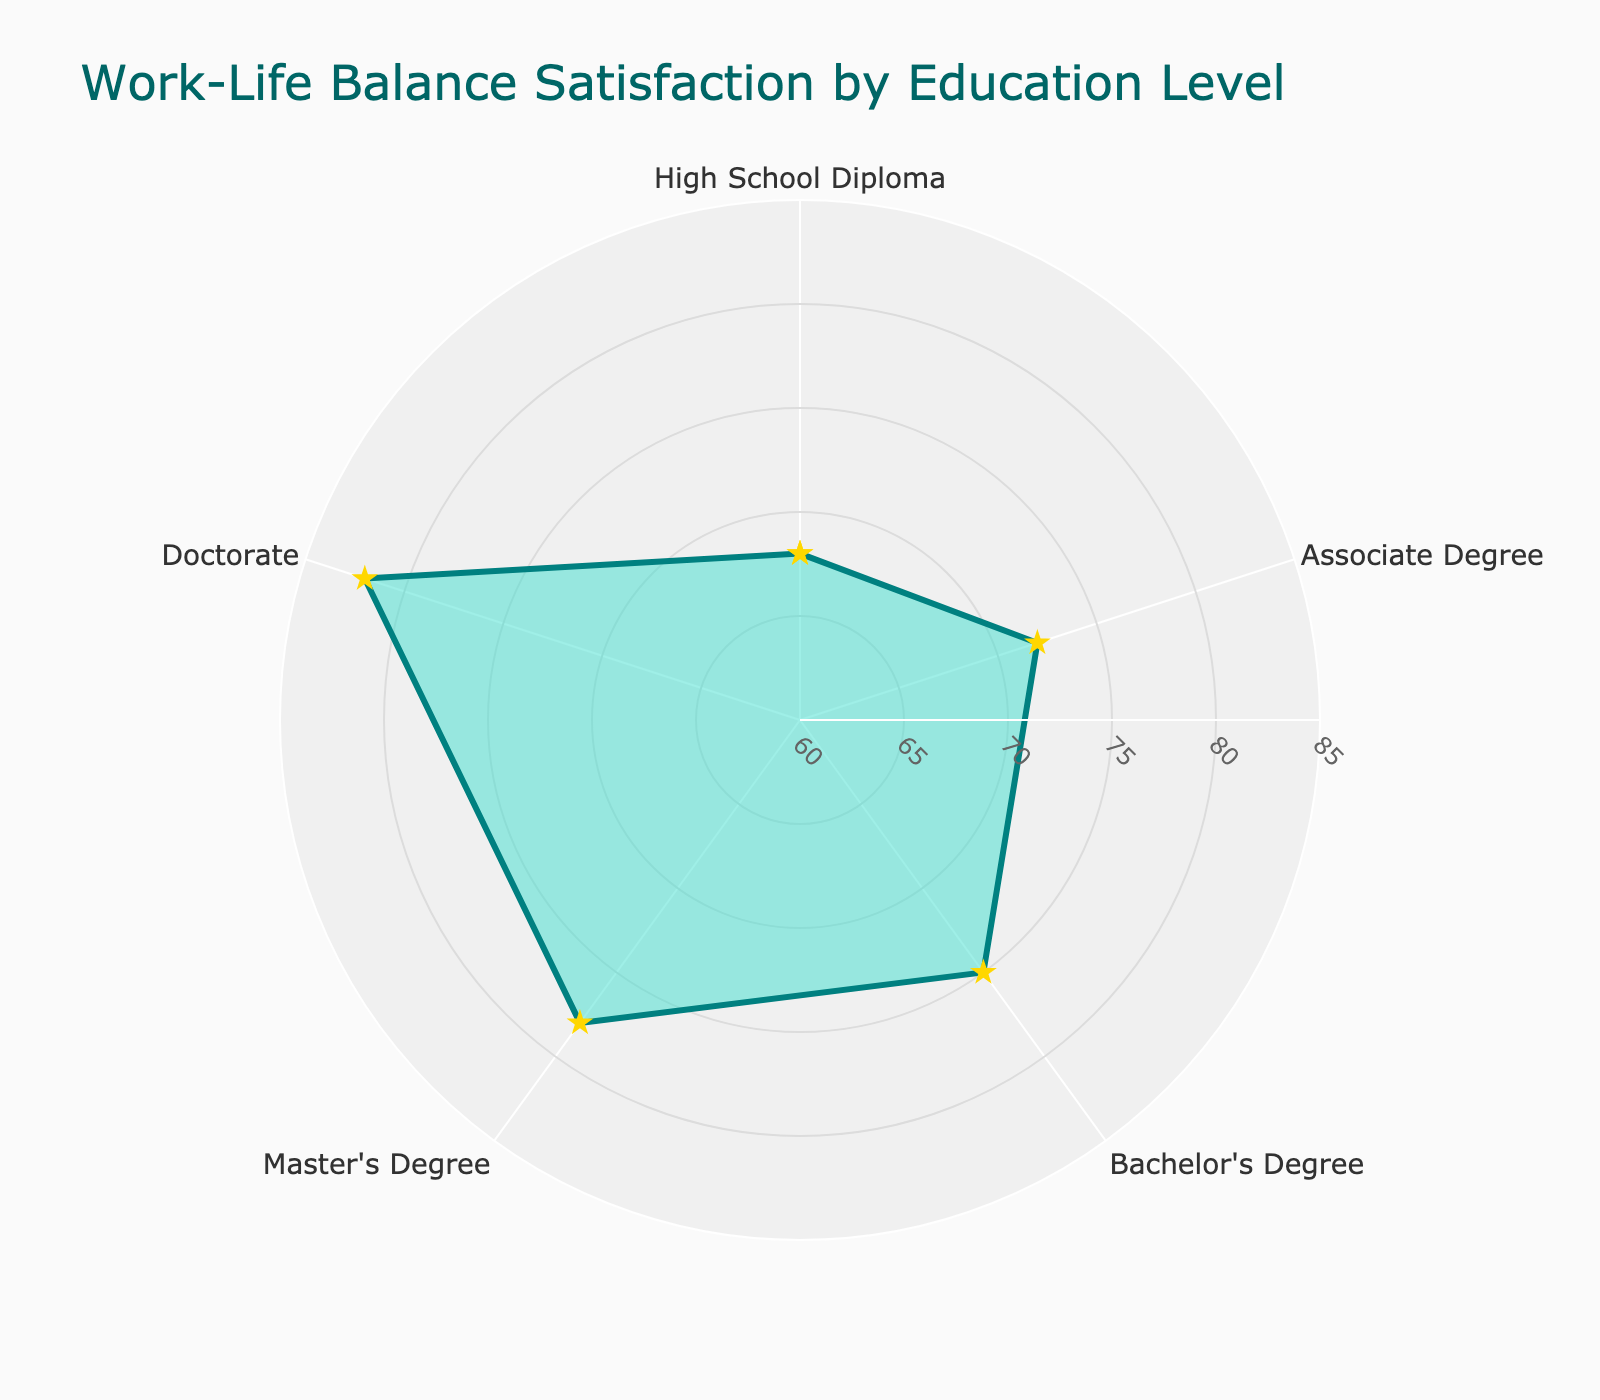what is the title of the radar chart? The title of the chart is located at the top and it summarizes the main topic of the chart. By reading the title, we can easily understand what the chart is about.
Answer: Work-Life Balance Satisfaction by Education Level what is the highest percentage of work-life balance satisfaction and which education level does it belong to? By looking at the largest value on the chart and identifying the corresponding education level, we can determine this information. The highest point is at 82%, corresponding to the Doctorate level.
Answer: 82%, Doctorate which education level has the lowest work-life balance satisfaction percentage? By identifying the lowest value on the chart and matching it with the corresponding education level, the lowest work-life balance satisfaction percentage can be found. The lowest point is at 68%, which corresponds to the High School Diploma level.
Answer: High School Diploma what is the range of work-life balance satisfaction percentages displayed in the radar chart? The range can be calculated by subtracting the lowest value from the highest value. Here, the highest value is 82% (Doctorate) and the lowest value is 68% (High School Diploma). The range is thus 82% - 68%.
Answer: 14% what's the average work-life balance satisfaction percentage across all education levels? To find the average, we sum up all the satisfaction percentages and then divide by the number of education levels: (68 + 72 + 75 + 78 + 82)/5. Adding these together gets 375, and dividing by 5 gives the average.
Answer: 75% which education levels have a work-life balance satisfaction percentage greater than 75%? By examining the percentages on the chart that are greater than 75%, we can determine which education levels meet this criterion. The percentages greater than 75% are 78% (Master's Degree) and 82% (Doctorate).
Answer: Master's Degree, Doctorate how many education levels are represented in the radar chart? We can count the number of unique education levels displayed around the radar chart. They are High School Diploma, Associate Degree, Bachelor's Degree, Master's Degree, and Doctorate.
Answer: 5 is the average work-life balance satisfaction closer to the Master's Degree or Bachelor's Degree percentage? First, calculate the differences: Master's Degree (78%) is 3% higher than the average (75%) and Bachelor's Degree (75%) is equal to the average. Therefore, the average is closer to the Bachelor's Degree percentage.
Answer: Bachelor's Degree what is the difference in work-life balance satisfaction between the Associate Degree and Doctorate levels? Subtract the percentage for the Associate Degree (72%) from the percentage for the Doctorate (82%) to find the difference. 82% - 72% equals 10%.
Answer: 10% what unique shape does the radar chart create and how is it formed? The radar chart creates a closed polygon shape by joining each data point in a circular layout, each representing a different education level with their respective satisfaction percentages, and finally connecting the last point back to the first.
Answer: closed polygon 